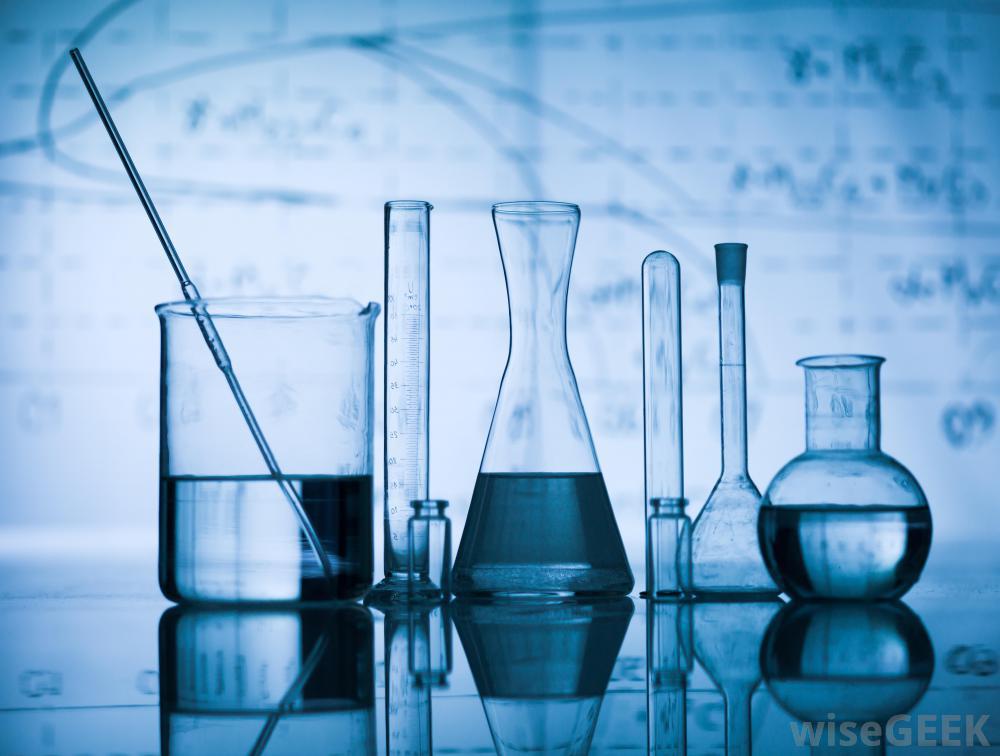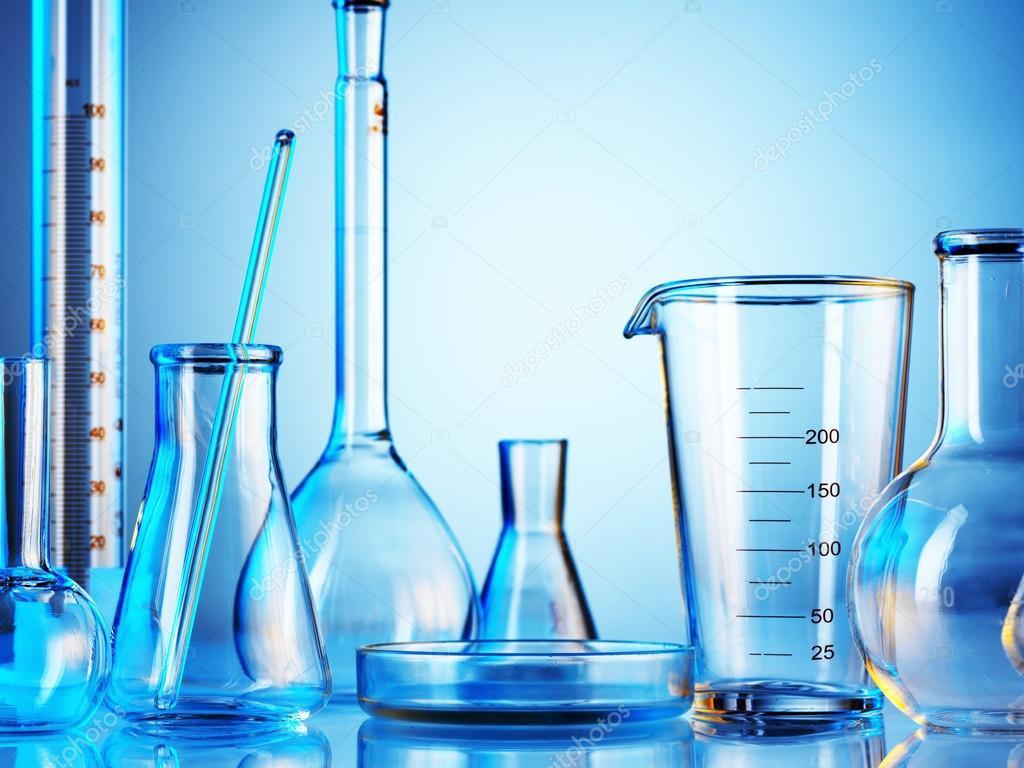The first image is the image on the left, the second image is the image on the right. Considering the images on both sides, is "There are exactly three object in one of the images." valid? Answer yes or no. No. The first image is the image on the left, the second image is the image on the right. Examine the images to the left and right. Is the description "The containers in the image on the left are set up near a blue light." accurate? Answer yes or no. Yes. 